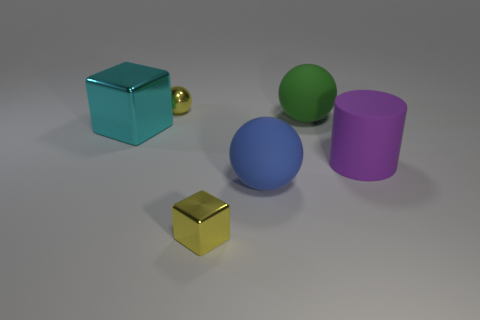Subtract all yellow metallic spheres. How many spheres are left? 2 Subtract 2 balls. How many balls are left? 1 Add 4 big cyan cubes. How many objects exist? 10 Subtract all blue balls. How many balls are left? 2 Add 6 metallic cubes. How many metallic cubes are left? 8 Add 2 small yellow metallic things. How many small yellow metallic things exist? 4 Subtract 1 yellow spheres. How many objects are left? 5 Subtract all cylinders. How many objects are left? 5 Subtract all brown spheres. Subtract all green blocks. How many spheres are left? 3 Subtract all green balls. How many cyan cylinders are left? 0 